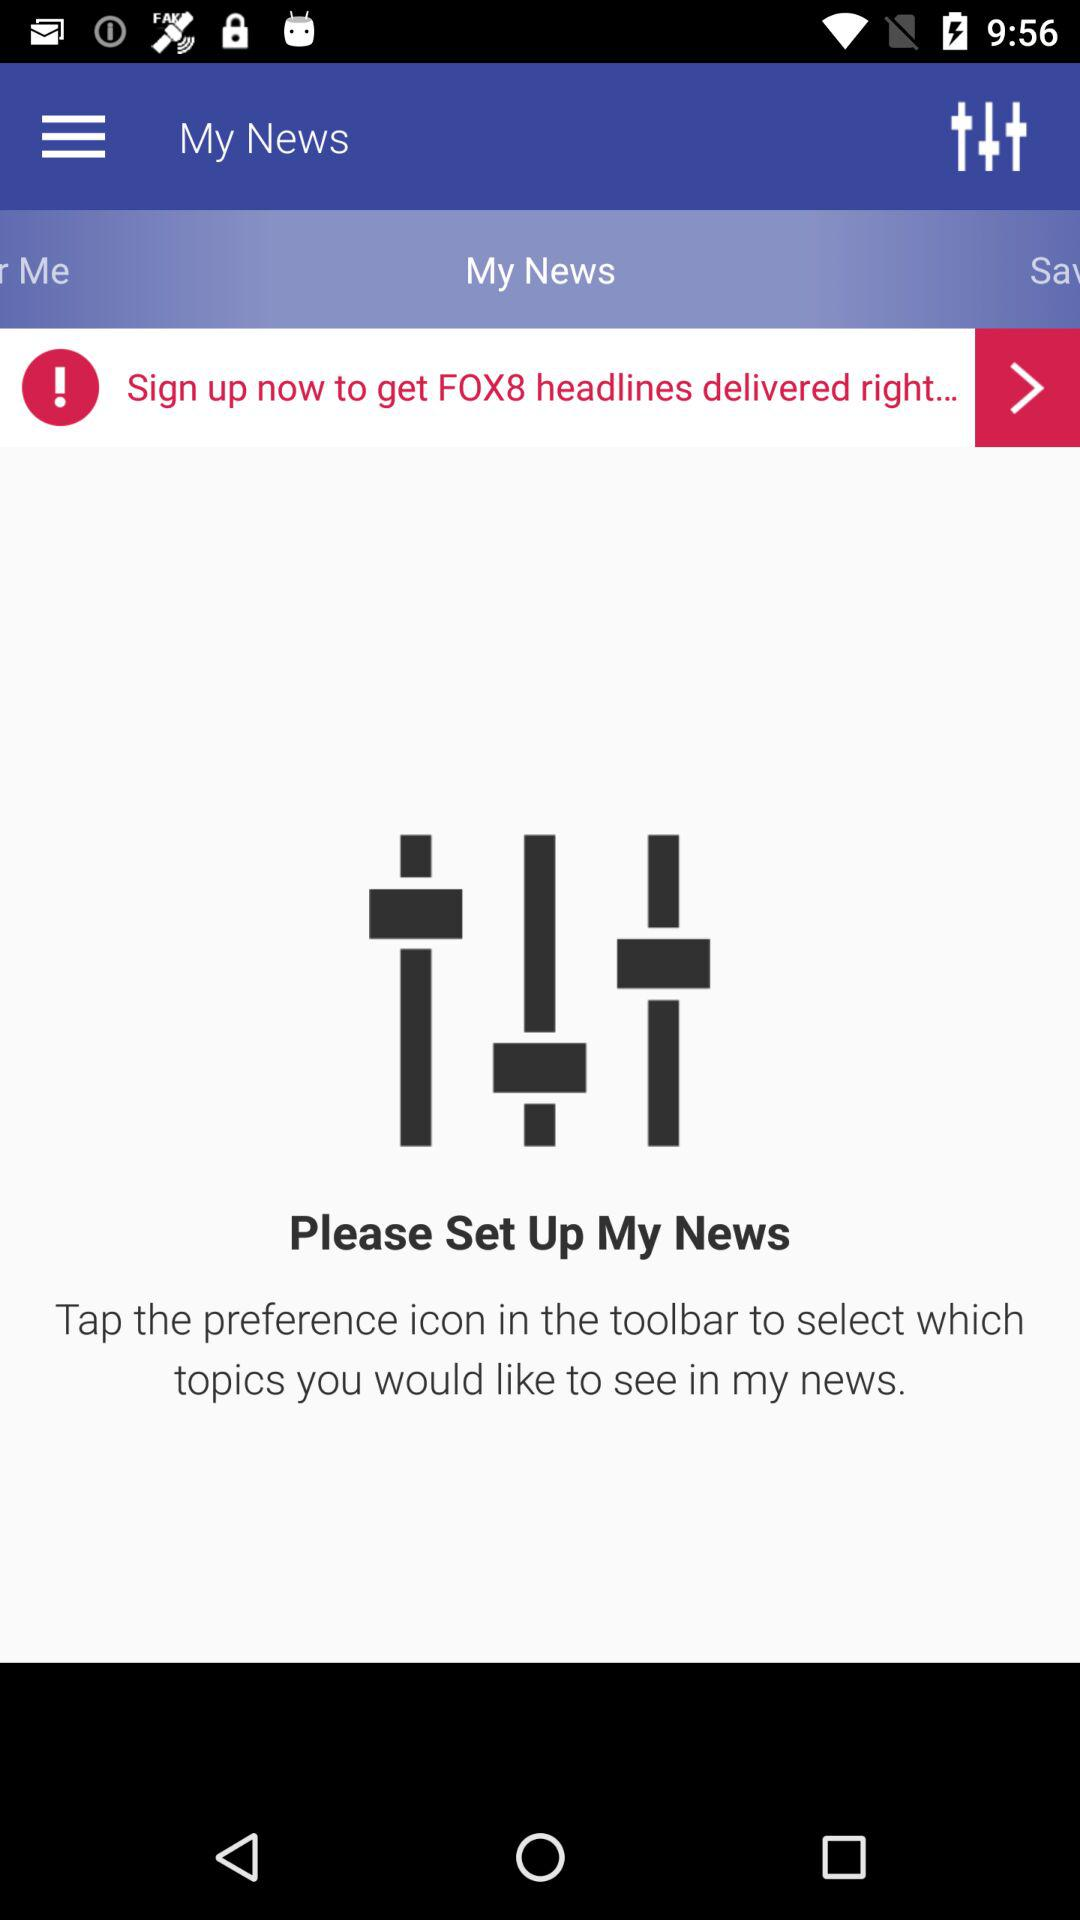Why do we have to sign up? You have to sign up to "get FOX8 headlines delivered right...". 